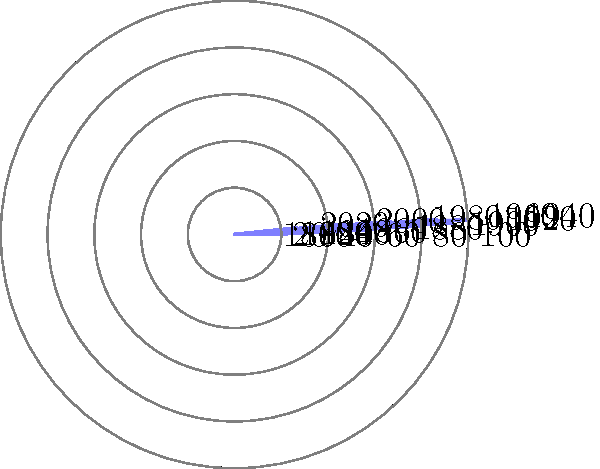The polar histogram shows the percentage of urban population in a country from 1800 to 2020. Which period saw the most rapid increase in urbanization, and what economic factors likely contributed to this shift? To answer this question, we need to analyze the data presented in the polar histogram and connect it to our knowledge of economic history:

1. Examine the data:
   The polar histogram shows the percentage of urban population from 1800 to 2020, with each spoke representing a 20-year interval.

2. Identify the period of most rapid increase:
   The steepest increase appears to be between 1860 and 1920, with the most dramatic rise occurring from 1880 to 1900.

3. Calculate the rate of change:
   The urban population percentage increased from approximately 30% in 1860 to 70% in 1920, a 40 percentage point increase over 60 years.

4. Economic factors contributing to this shift:
   a) Industrial Revolution: This period coincides with the Second Industrial Revolution (1870-1914), characterized by rapid industrialization and technological advancements.
   
   b) Factory system: The growth of factories in urban areas created a high demand for labor, attracting rural populations to cities.
   
   c) Agricultural mechanization: Improvements in farming technology reduced the need for agricultural labor, pushing rural workers to seek employment in urban industries.
   
   d) Transportation developments: The expansion of railroads and other transportation systems made it easier for people to move from rural to urban areas.
   
   e) Higher wages: Urban industries often offered higher wages compared to agricultural work, incentivizing rural-to-urban migration.
   
   f) Economies of agglomeration: The concentration of industries in cities created positive externalities, further driving urbanization.

5. Connect to economic theory:
   This rapid urbanization aligns with theories of structural transformation in economics, where labor shifts from agriculture to manufacturing and services as economies develop.

The most rapid increase in urbanization occurred between 1880 and 1920, driven by industrialization, technological advancements, and economic incentives associated with the Second Industrial Revolution.
Answer: 1880-1920; industrialization, technological advancements, and economic incentives of the Second Industrial Revolution. 